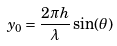Convert formula to latex. <formula><loc_0><loc_0><loc_500><loc_500>y _ { 0 } = \frac { 2 \pi h } { \lambda } \sin ( \theta )</formula> 